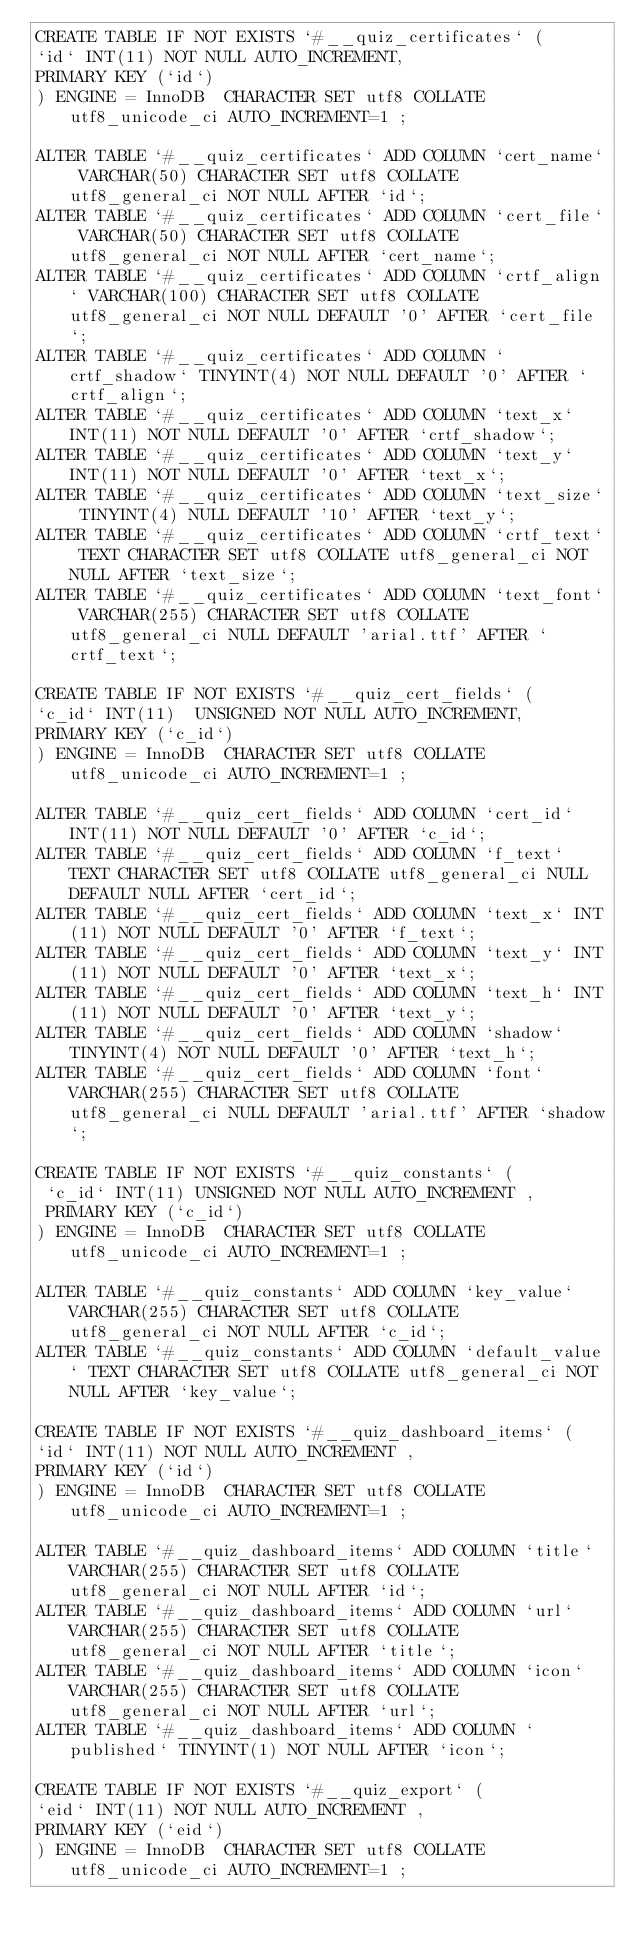<code> <loc_0><loc_0><loc_500><loc_500><_SQL_>CREATE TABLE IF NOT EXISTS `#__quiz_certificates` (
`id` INT(11) NOT NULL AUTO_INCREMENT,
PRIMARY KEY (`id`)
) ENGINE = InnoDB  CHARACTER SET utf8 COLLATE utf8_unicode_ci AUTO_INCREMENT=1 ;

ALTER TABLE `#__quiz_certificates` ADD COLUMN `cert_name` VARCHAR(50) CHARACTER SET utf8 COLLATE utf8_general_ci NOT NULL AFTER `id`;
ALTER TABLE `#__quiz_certificates` ADD COLUMN `cert_file` VARCHAR(50) CHARACTER SET utf8 COLLATE utf8_general_ci NOT NULL AFTER `cert_name`;
ALTER TABLE `#__quiz_certificates` ADD COLUMN `crtf_align` VARCHAR(100) CHARACTER SET utf8 COLLATE utf8_general_ci NOT NULL DEFAULT '0' AFTER `cert_file`;
ALTER TABLE `#__quiz_certificates` ADD COLUMN `crtf_shadow` TINYINT(4) NOT NULL DEFAULT '0' AFTER `crtf_align`;
ALTER TABLE `#__quiz_certificates` ADD COLUMN `text_x` INT(11) NOT NULL DEFAULT '0' AFTER `crtf_shadow`;
ALTER TABLE `#__quiz_certificates` ADD COLUMN `text_y` INT(11) NOT NULL DEFAULT '0' AFTER `text_x`;
ALTER TABLE `#__quiz_certificates` ADD COLUMN `text_size` TINYINT(4) NULL DEFAULT '10' AFTER `text_y`;
ALTER TABLE `#__quiz_certificates` ADD COLUMN `crtf_text` TEXT CHARACTER SET utf8 COLLATE utf8_general_ci NOT NULL AFTER `text_size`;
ALTER TABLE `#__quiz_certificates` ADD COLUMN `text_font` VARCHAR(255) CHARACTER SET utf8 COLLATE utf8_general_ci NULL DEFAULT 'arial.ttf' AFTER `crtf_text`;

CREATE TABLE IF NOT EXISTS `#__quiz_cert_fields` (
`c_id` INT(11)  UNSIGNED NOT NULL AUTO_INCREMENT,
PRIMARY KEY (`c_id`)
) ENGINE = InnoDB  CHARACTER SET utf8 COLLATE utf8_unicode_ci AUTO_INCREMENT=1 ;

ALTER TABLE `#__quiz_cert_fields` ADD COLUMN `cert_id` INT(11) NOT NULL DEFAULT '0' AFTER `c_id`;
ALTER TABLE `#__quiz_cert_fields` ADD COLUMN `f_text` TEXT CHARACTER SET utf8 COLLATE utf8_general_ci NULL DEFAULT NULL AFTER `cert_id`;
ALTER TABLE `#__quiz_cert_fields` ADD COLUMN `text_x` INT(11) NOT NULL DEFAULT '0' AFTER `f_text`;
ALTER TABLE `#__quiz_cert_fields` ADD COLUMN `text_y` INT(11) NOT NULL DEFAULT '0' AFTER `text_x`;
ALTER TABLE `#__quiz_cert_fields` ADD COLUMN `text_h` INT(11) NOT NULL DEFAULT '0' AFTER `text_y`;
ALTER TABLE `#__quiz_cert_fields` ADD COLUMN `shadow` TINYINT(4) NOT NULL DEFAULT '0' AFTER `text_h`;
ALTER TABLE `#__quiz_cert_fields` ADD COLUMN `font` VARCHAR(255) CHARACTER SET utf8 COLLATE utf8_general_ci NULL DEFAULT 'arial.ttf' AFTER `shadow`;

CREATE TABLE IF NOT EXISTS `#__quiz_constants` (
 `c_id` INT(11) UNSIGNED NOT NULL AUTO_INCREMENT ,
 PRIMARY KEY (`c_id`)
) ENGINE = InnoDB  CHARACTER SET utf8 COLLATE utf8_unicode_ci AUTO_INCREMENT=1 ;

ALTER TABLE `#__quiz_constants` ADD COLUMN `key_value` VARCHAR(255) CHARACTER SET utf8 COLLATE utf8_general_ci NOT NULL AFTER `c_id`;
ALTER TABLE `#__quiz_constants` ADD COLUMN `default_value` TEXT CHARACTER SET utf8 COLLATE utf8_general_ci NOT NULL AFTER `key_value`;

CREATE TABLE IF NOT EXISTS `#__quiz_dashboard_items` (
`id` INT(11) NOT NULL AUTO_INCREMENT ,
PRIMARY KEY (`id`)
) ENGINE = InnoDB  CHARACTER SET utf8 COLLATE utf8_unicode_ci AUTO_INCREMENT=1 ;

ALTER TABLE `#__quiz_dashboard_items` ADD COLUMN `title` VARCHAR(255) CHARACTER SET utf8 COLLATE utf8_general_ci NOT NULL AFTER `id`;
ALTER TABLE `#__quiz_dashboard_items` ADD COLUMN `url` VARCHAR(255) CHARACTER SET utf8 COLLATE utf8_general_ci NOT NULL AFTER `title`;
ALTER TABLE `#__quiz_dashboard_items` ADD COLUMN `icon` VARCHAR(255) CHARACTER SET utf8 COLLATE utf8_general_ci NOT NULL AFTER `url`;
ALTER TABLE `#__quiz_dashboard_items` ADD COLUMN `published` TINYINT(1) NOT NULL AFTER `icon`;

CREATE TABLE IF NOT EXISTS `#__quiz_export` (
`eid` INT(11) NOT NULL AUTO_INCREMENT ,
PRIMARY KEY (`eid`)
) ENGINE = InnoDB  CHARACTER SET utf8 COLLATE utf8_unicode_ci AUTO_INCREMENT=1 ;
</code> 